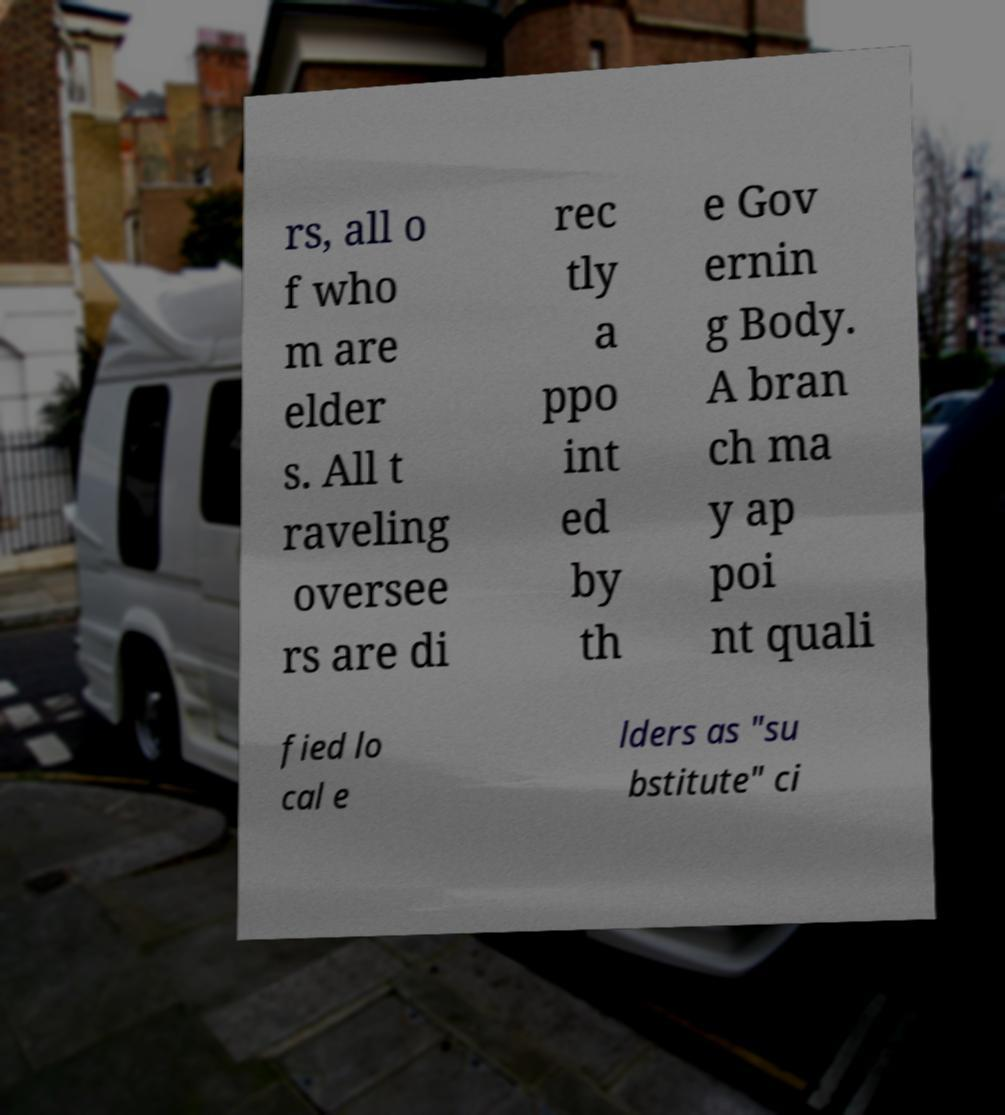What messages or text are displayed in this image? I need them in a readable, typed format. rs, all o f who m are elder s. All t raveling oversee rs are di rec tly a ppo int ed by th e Gov ernin g Body. A bran ch ma y ap poi nt quali fied lo cal e lders as "su bstitute" ci 